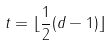<formula> <loc_0><loc_0><loc_500><loc_500>t = \lfloor \frac { 1 } { 2 } ( d - 1 ) \rfloor</formula> 